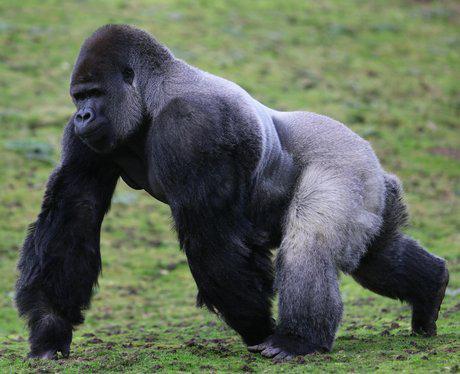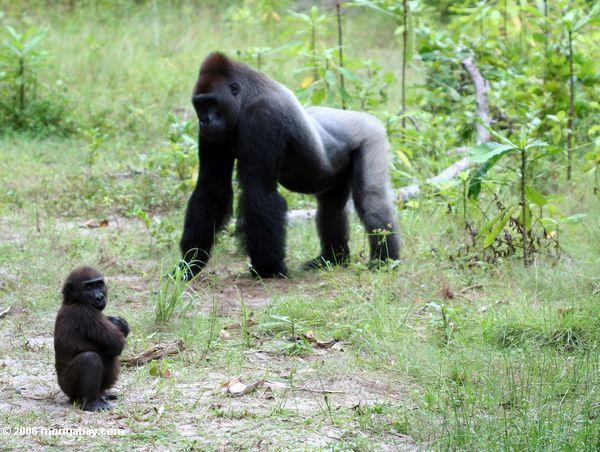The first image is the image on the left, the second image is the image on the right. Evaluate the accuracy of this statement regarding the images: "In one of the pictures, a baby gorilla is near an adult gorilla.". Is it true? Answer yes or no. Yes. The first image is the image on the left, the second image is the image on the right. Considering the images on both sides, is "Each image contains the same number of gorillas." valid? Answer yes or no. No. 